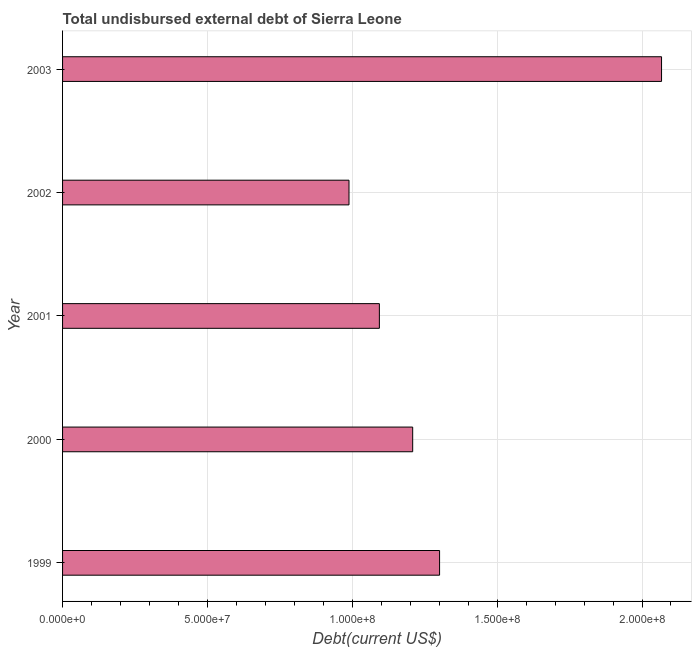What is the title of the graph?
Provide a succinct answer. Total undisbursed external debt of Sierra Leone. What is the label or title of the X-axis?
Your response must be concise. Debt(current US$). What is the total debt in 2001?
Keep it short and to the point. 1.09e+08. Across all years, what is the maximum total debt?
Keep it short and to the point. 2.07e+08. Across all years, what is the minimum total debt?
Your answer should be compact. 9.89e+07. In which year was the total debt maximum?
Provide a succinct answer. 2003. What is the sum of the total debt?
Offer a terse response. 6.66e+08. What is the difference between the total debt in 1999 and 2002?
Your answer should be compact. 3.13e+07. What is the average total debt per year?
Your response must be concise. 1.33e+08. What is the median total debt?
Ensure brevity in your answer.  1.21e+08. What is the ratio of the total debt in 2000 to that in 2001?
Provide a short and direct response. 1.1. Is the difference between the total debt in 2001 and 2002 greater than the difference between any two years?
Keep it short and to the point. No. What is the difference between the highest and the second highest total debt?
Your answer should be very brief. 7.66e+07. Is the sum of the total debt in 1999 and 2002 greater than the maximum total debt across all years?
Ensure brevity in your answer.  Yes. What is the difference between the highest and the lowest total debt?
Your answer should be compact. 1.08e+08. In how many years, is the total debt greater than the average total debt taken over all years?
Offer a terse response. 1. How many bars are there?
Ensure brevity in your answer.  5. Are the values on the major ticks of X-axis written in scientific E-notation?
Your response must be concise. Yes. What is the Debt(current US$) in 1999?
Give a very brief answer. 1.30e+08. What is the Debt(current US$) in 2000?
Ensure brevity in your answer.  1.21e+08. What is the Debt(current US$) of 2001?
Provide a succinct answer. 1.09e+08. What is the Debt(current US$) in 2002?
Your response must be concise. 9.89e+07. What is the Debt(current US$) in 2003?
Offer a very short reply. 2.07e+08. What is the difference between the Debt(current US$) in 1999 and 2000?
Make the answer very short. 9.28e+06. What is the difference between the Debt(current US$) in 1999 and 2001?
Ensure brevity in your answer.  2.08e+07. What is the difference between the Debt(current US$) in 1999 and 2002?
Offer a very short reply. 3.13e+07. What is the difference between the Debt(current US$) in 1999 and 2003?
Keep it short and to the point. -7.66e+07. What is the difference between the Debt(current US$) in 2000 and 2001?
Your response must be concise. 1.15e+07. What is the difference between the Debt(current US$) in 2000 and 2002?
Offer a terse response. 2.20e+07. What is the difference between the Debt(current US$) in 2000 and 2003?
Ensure brevity in your answer.  -8.59e+07. What is the difference between the Debt(current US$) in 2001 and 2002?
Make the answer very short. 1.05e+07. What is the difference between the Debt(current US$) in 2001 and 2003?
Offer a very short reply. -9.74e+07. What is the difference between the Debt(current US$) in 2002 and 2003?
Provide a short and direct response. -1.08e+08. What is the ratio of the Debt(current US$) in 1999 to that in 2000?
Give a very brief answer. 1.08. What is the ratio of the Debt(current US$) in 1999 to that in 2001?
Your answer should be compact. 1.19. What is the ratio of the Debt(current US$) in 1999 to that in 2002?
Your response must be concise. 1.32. What is the ratio of the Debt(current US$) in 1999 to that in 2003?
Your response must be concise. 0.63. What is the ratio of the Debt(current US$) in 2000 to that in 2001?
Offer a very short reply. 1.1. What is the ratio of the Debt(current US$) in 2000 to that in 2002?
Provide a succinct answer. 1.22. What is the ratio of the Debt(current US$) in 2000 to that in 2003?
Your response must be concise. 0.58. What is the ratio of the Debt(current US$) in 2001 to that in 2002?
Keep it short and to the point. 1.11. What is the ratio of the Debt(current US$) in 2001 to that in 2003?
Keep it short and to the point. 0.53. What is the ratio of the Debt(current US$) in 2002 to that in 2003?
Ensure brevity in your answer.  0.48. 